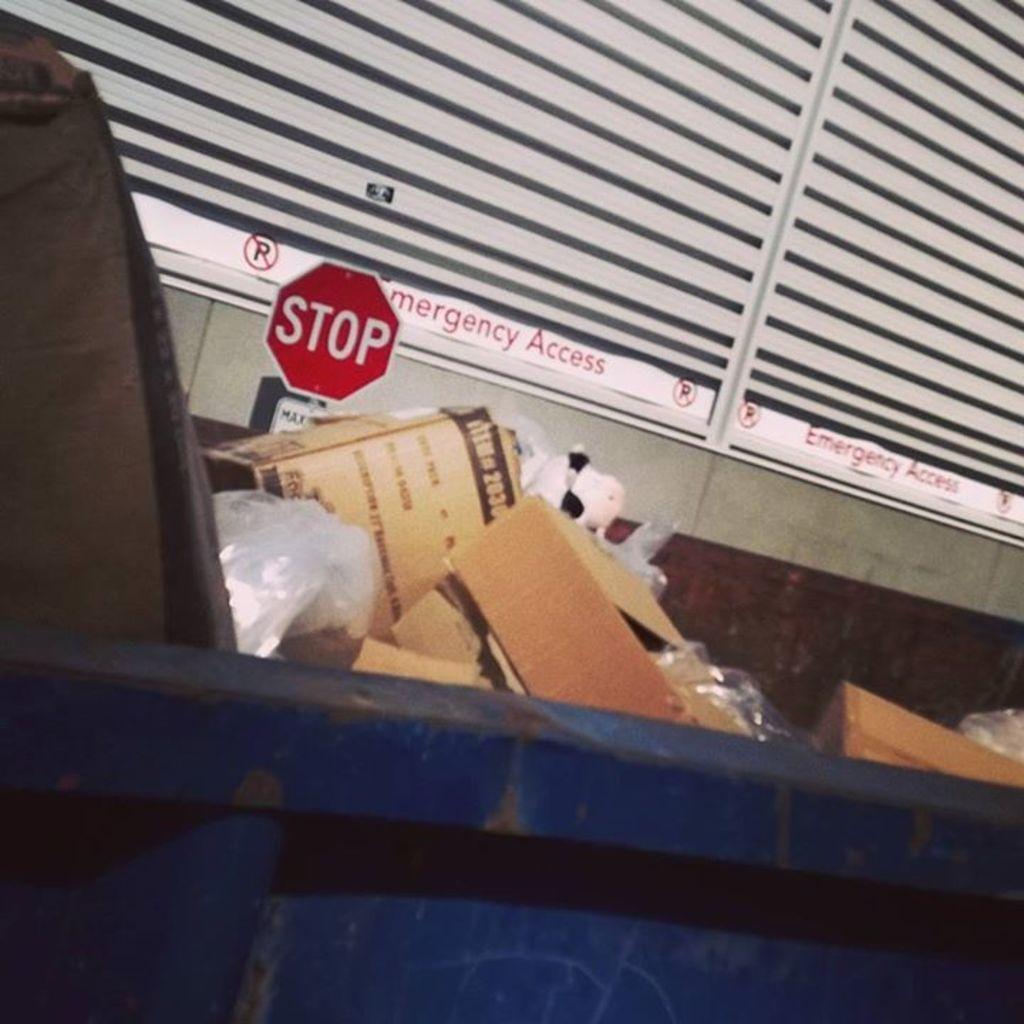Can you describe this image briefly? In this image there is a trash, in that trash there is some waste, in the background there is a stop board and windows. 